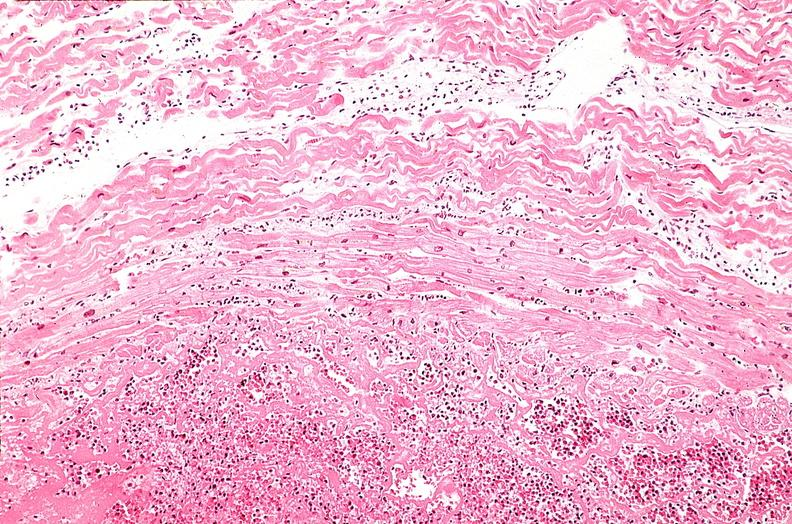where is this from?
Answer the question using a single word or phrase. Heart 